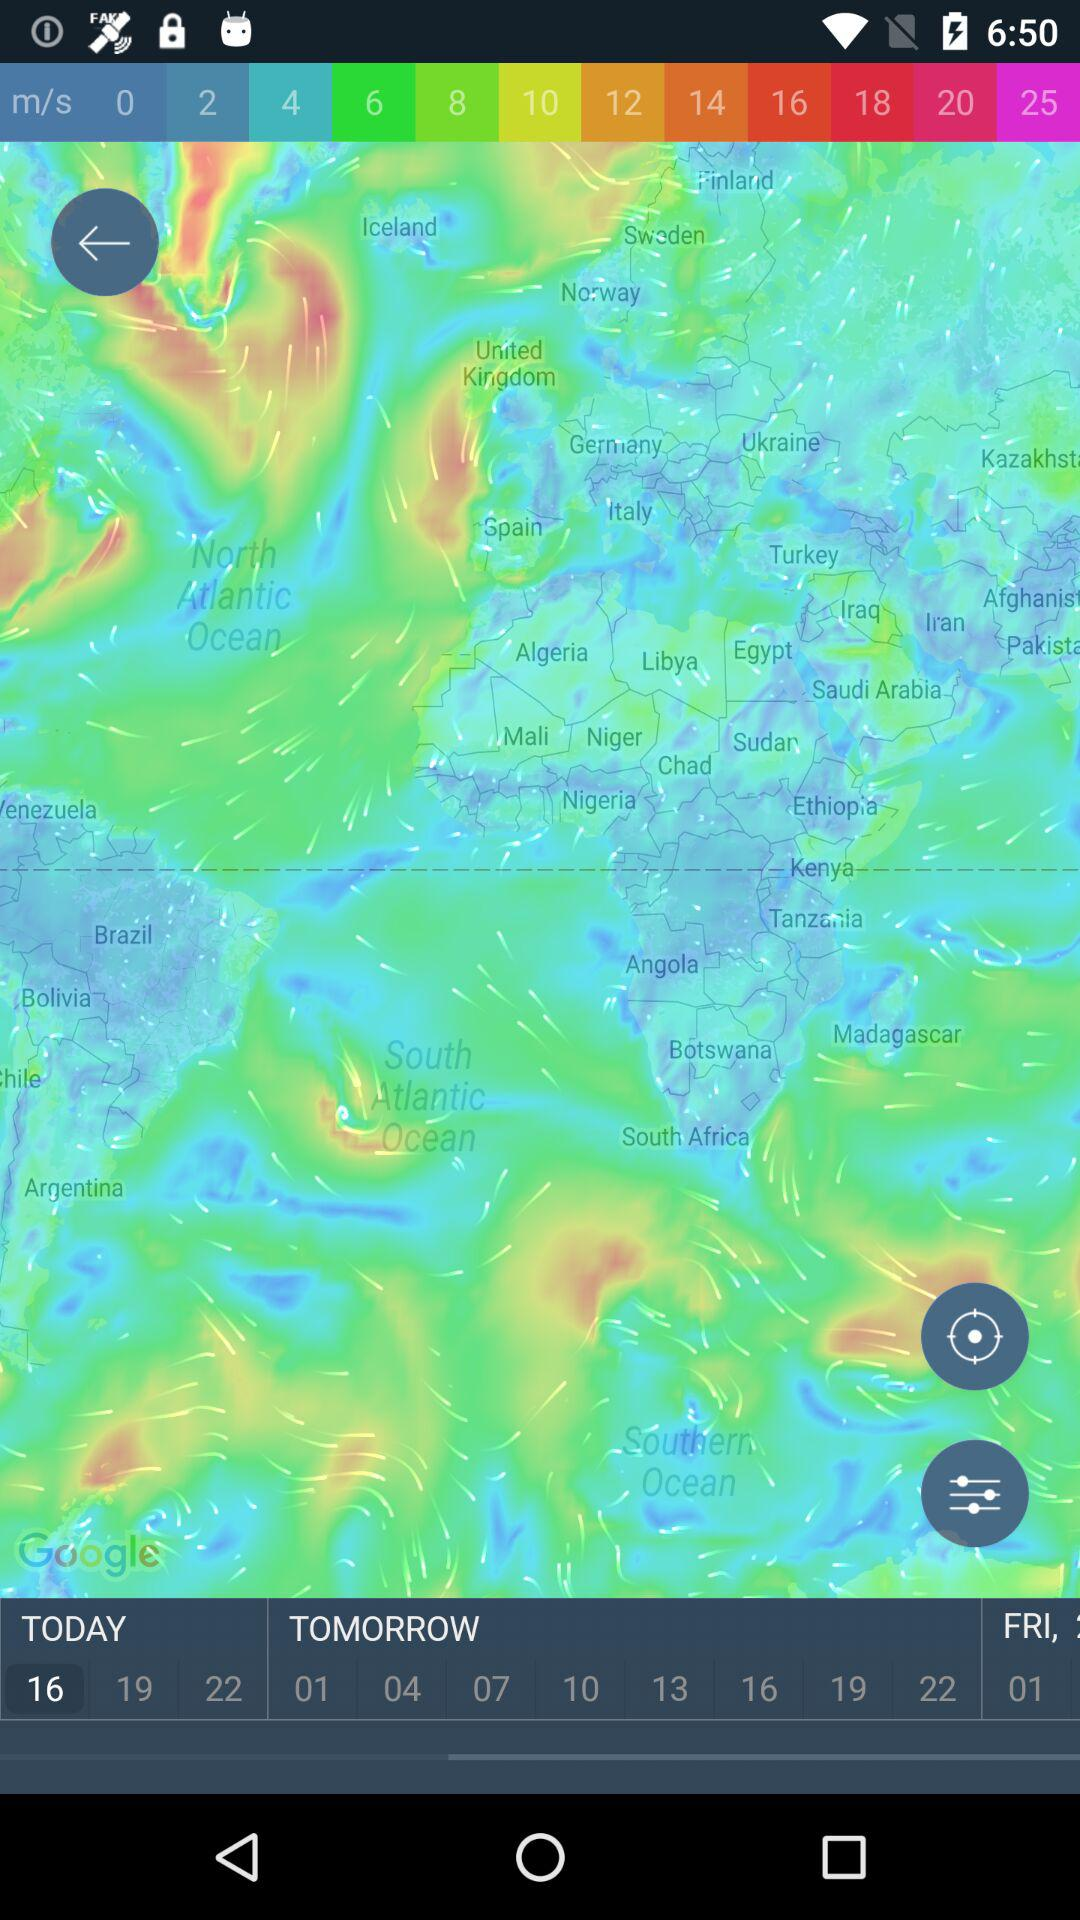What day has been chosen? The chosen day is "TODAY". 